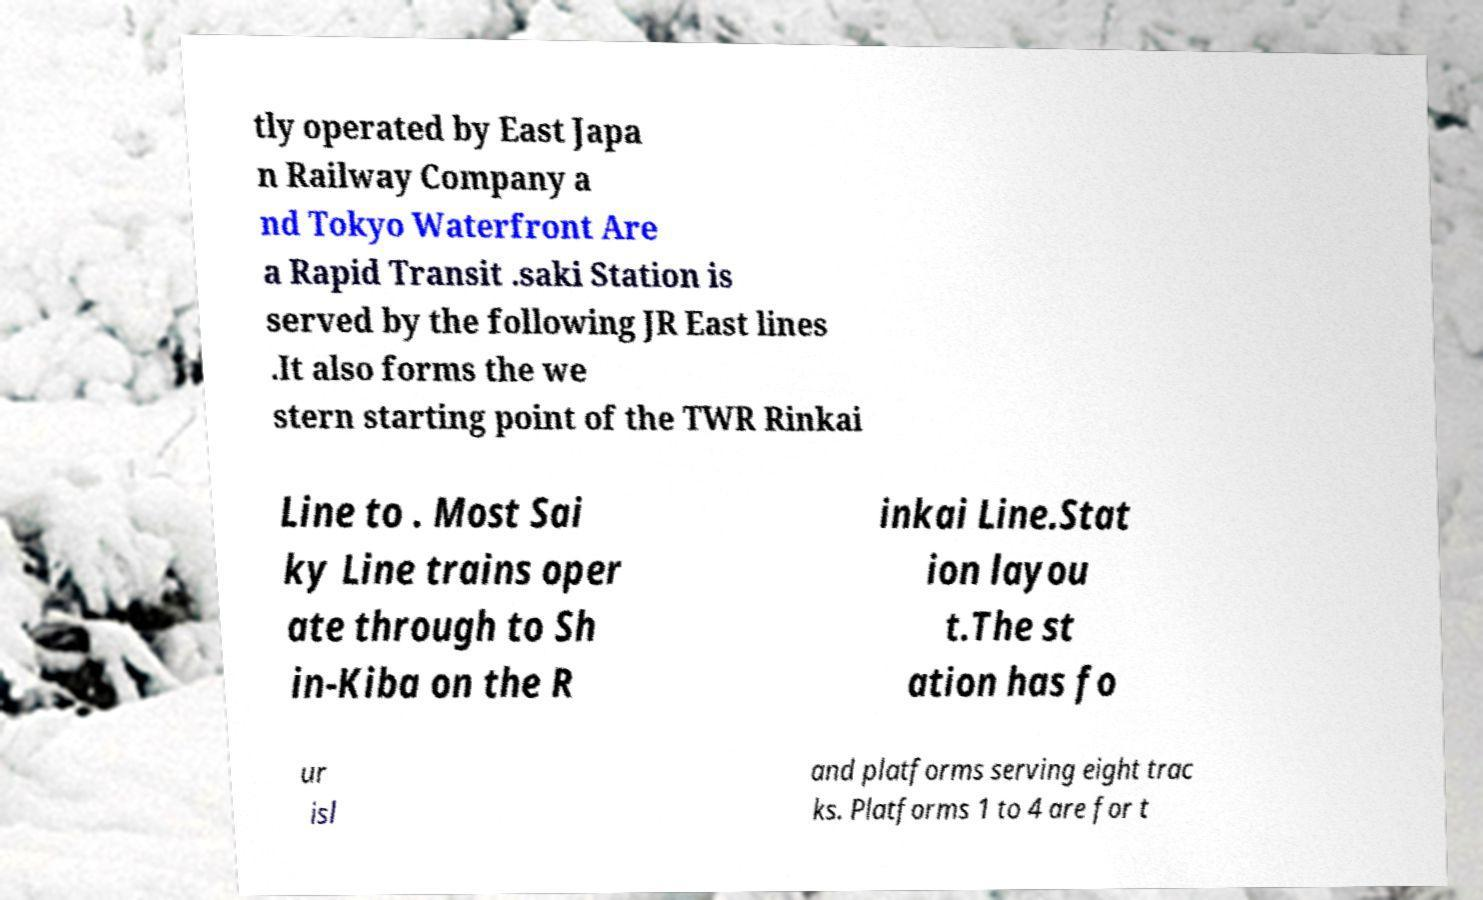Can you accurately transcribe the text from the provided image for me? tly operated by East Japa n Railway Company a nd Tokyo Waterfront Are a Rapid Transit .saki Station is served by the following JR East lines .It also forms the we stern starting point of the TWR Rinkai Line to . Most Sai ky Line trains oper ate through to Sh in-Kiba on the R inkai Line.Stat ion layou t.The st ation has fo ur isl and platforms serving eight trac ks. Platforms 1 to 4 are for t 